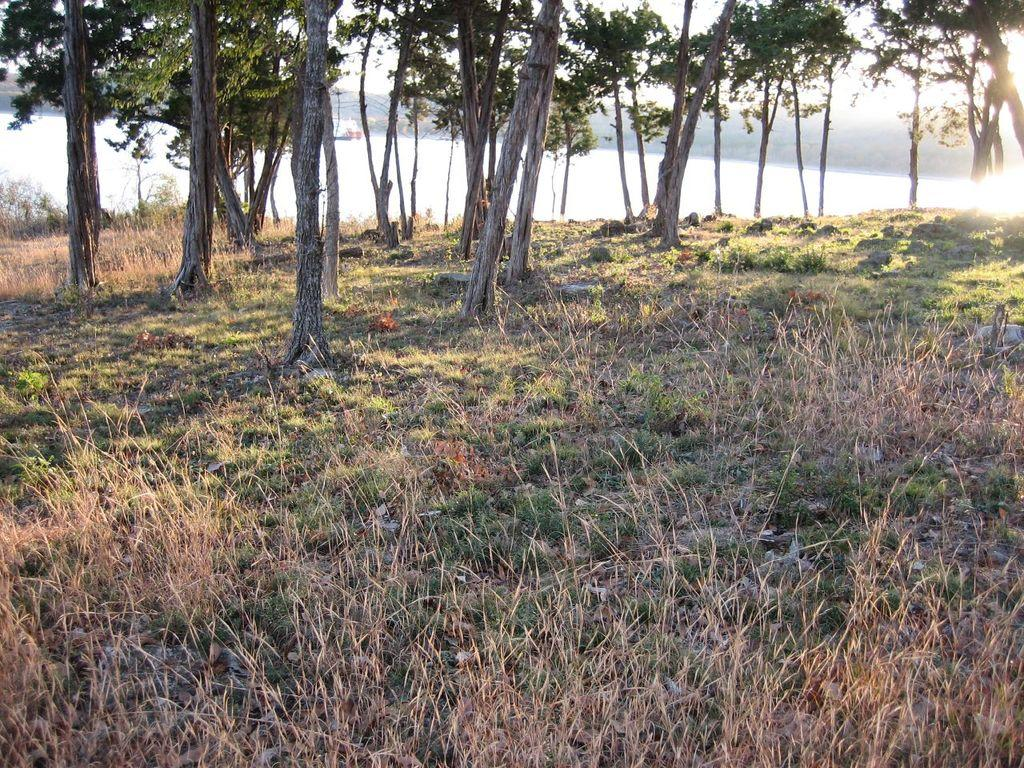What is the ground surface like in the image? The ground in the image is covered with dry grass. What type of vegetation can be seen in the area? There are many trees in the area. What natural feature is visible in the image? There is a river visible in the image. What type of receipt is lying on the riverbank in the image? There is no receipt present in the image; it only features dry grass, trees, and a river. 